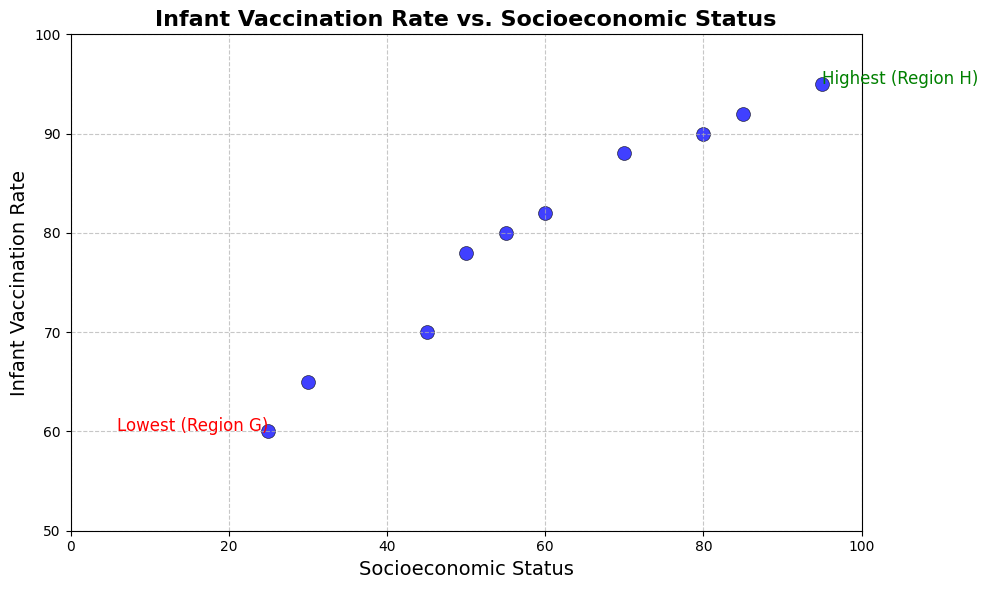What region has the highest infant vaccination rate? By examining the text annotation on the figure marking the highest vaccination rate, it is labeled as the "Highest" point. The region with the highest vaccination rate is clearly marked.
Answer: Region H What region has the lowest infant vaccination rate? By looking at the text annotation on the figure marking the lowest vaccination rate, it is labeled as the "Lowest" point. The region with the lowest vaccination rate is clearly marked.
Answer: Region G What is the socioeconomic status of the region with the lowest vaccination rate? Check the annotation for the lowest vaccination rate region. The socioeconomic status value for this region is given alongside the annotation.
Answer: 25 What is the difference in socioeconomic status between the regions with the highest and lowest vaccination rates? Subtract the socioeconomic status of the region with the lowest vaccination rate (Region G, 25) from the region with the highest vaccination rate (Region H, 95).
Answer: 70 Is there a noticeable trend between socioeconomic status and infant vaccination rate? By looking at the scatter plot as a whole, observe the general direction of the points. Higher socioeconomic statuses generally appear to correspond to higher vaccination rates, indicating a positive trend.
Answer: Yes, a positive trend Which region has a socioeconomic status closest to 50? Identify the data point with a socioeconomic status closest to 50 by comparing all points plotted. Region C has a socioeconomic status of 50.
Answer: Region C Which regions have vaccination rates above 90? Identify points on the scatter plot with vaccination rates higher than 90. The regions are Region A, Region H, and Region I.
Answer: Regions A, H, I What is the average infant vaccination rate among all regions? Sum all vaccination rates: 92 + 88 + 78 + 70 + 82 + 65 + 60 + 95 + 90 + 80 = 800. There are 10 regions; thus, the average is 800/10.
Answer: 80 What is the difference in infant vaccination rates between Region D and Region J? Subtract the vaccination rate of Region D (70) from the vaccination rate of Region J (80).
Answer: 10 Does Region B have a higher or lower socioeconomic status compared to Region E? Compare the socioeconomic statuses: Region B has a status of 70 and Region E has a status of 60.
Answer: Higher 